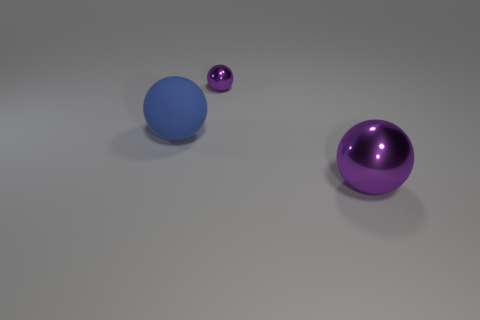Subtract all big balls. How many balls are left? 1 Subtract all blue balls. How many balls are left? 2 Add 2 small cyan rubber cubes. How many objects exist? 5 Subtract 1 balls. How many balls are left? 2 Add 1 tiny blue things. How many tiny blue things exist? 1 Subtract 0 brown cubes. How many objects are left? 3 Subtract all green spheres. Subtract all cyan blocks. How many spheres are left? 3 Subtract all gray blocks. How many brown balls are left? 0 Subtract all big objects. Subtract all rubber objects. How many objects are left? 0 Add 1 large things. How many large things are left? 3 